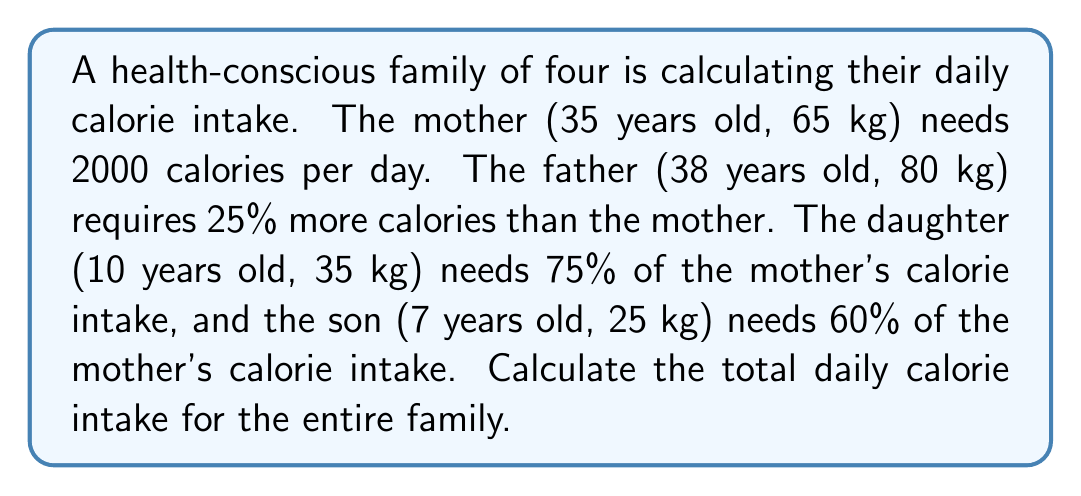Solve this math problem. Let's break this down step by step:

1. Mother's calorie intake:
   Given as 2000 calories per day.

2. Father's calorie intake:
   $$\text{Father's calories} = \text{Mother's calories} \times 1.25$$
   $$\text{Father's calories} = 2000 \times 1.25 = 2500 \text{ calories}$$

3. Daughter's calorie intake:
   $$\text{Daughter's calories} = \text{Mother's calories} \times 0.75$$
   $$\text{Daughter's calories} = 2000 \times 0.75 = 1500 \text{ calories}$$

4. Son's calorie intake:
   $$\text{Son's calories} = \text{Mother's calories} \times 0.60$$
   $$\text{Son's calories} = 2000 \times 0.60 = 1200 \text{ calories}$$

5. Total family calorie intake:
   $$\text{Total calories} = \text{Mother} + \text{Father} + \text{Daughter} + \text{Son}$$
   $$\text{Total calories} = 2000 + 2500 + 1500 + 1200$$
   $$\text{Total calories} = 7200 \text{ calories}$$
Answer: The total daily calorie intake for the entire family is 7200 calories. 